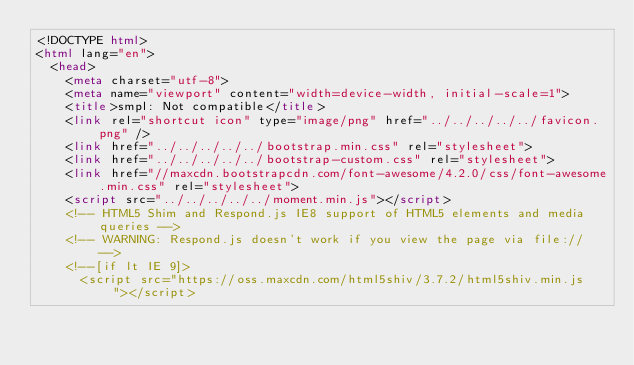<code> <loc_0><loc_0><loc_500><loc_500><_HTML_><!DOCTYPE html>
<html lang="en">
  <head>
    <meta charset="utf-8">
    <meta name="viewport" content="width=device-width, initial-scale=1">
    <title>smpl: Not compatible</title>
    <link rel="shortcut icon" type="image/png" href="../../../../../favicon.png" />
    <link href="../../../../../bootstrap.min.css" rel="stylesheet">
    <link href="../../../../../bootstrap-custom.css" rel="stylesheet">
    <link href="//maxcdn.bootstrapcdn.com/font-awesome/4.2.0/css/font-awesome.min.css" rel="stylesheet">
    <script src="../../../../../moment.min.js"></script>
    <!-- HTML5 Shim and Respond.js IE8 support of HTML5 elements and media queries -->
    <!-- WARNING: Respond.js doesn't work if you view the page via file:// -->
    <!--[if lt IE 9]>
      <script src="https://oss.maxcdn.com/html5shiv/3.7.2/html5shiv.min.js"></script></code> 